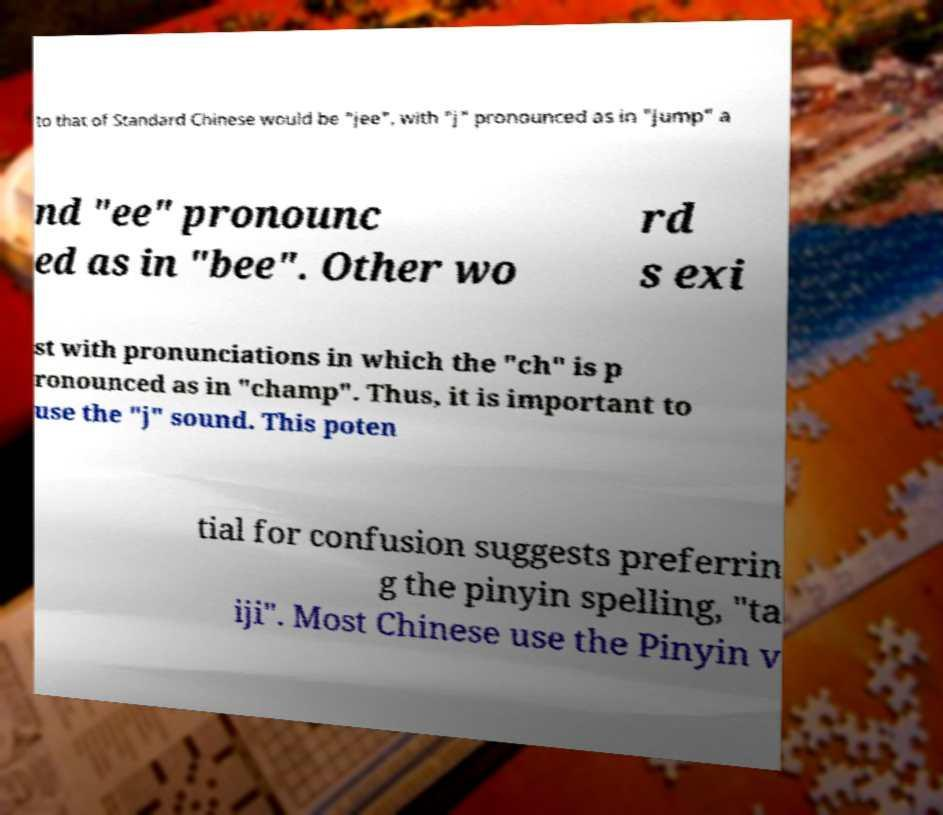I need the written content from this picture converted into text. Can you do that? to that of Standard Chinese would be "jee", with "j" pronounced as in "jump" a nd "ee" pronounc ed as in "bee". Other wo rd s exi st with pronunciations in which the "ch" is p ronounced as in "champ". Thus, it is important to use the "j" sound. This poten tial for confusion suggests preferrin g the pinyin spelling, "ta iji". Most Chinese use the Pinyin v 